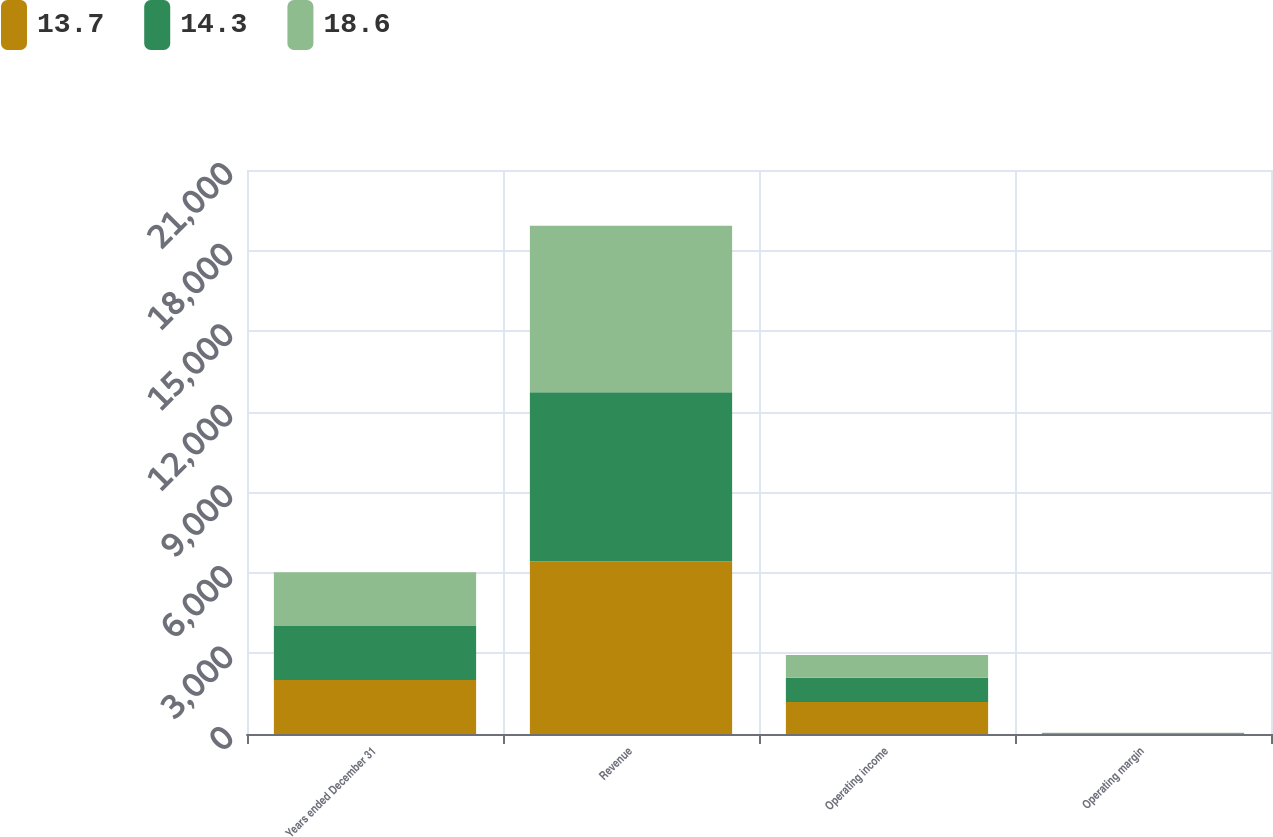<chart> <loc_0><loc_0><loc_500><loc_500><stacked_bar_chart><ecel><fcel>Years ended December 31<fcel>Revenue<fcel>Operating income<fcel>Operating margin<nl><fcel>13.7<fcel>2010<fcel>6423<fcel>1194<fcel>18.6<nl><fcel>14.3<fcel>2009<fcel>6305<fcel>900<fcel>14.3<nl><fcel>18.6<fcel>2008<fcel>6197<fcel>846<fcel>13.7<nl></chart> 